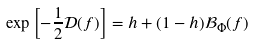Convert formula to latex. <formula><loc_0><loc_0><loc_500><loc_500>\exp \left [ - \frac { 1 } { 2 } \mathcal { D } ( f ) \right ] = h + ( 1 - h ) \mathcal { B } _ { \Phi } ( f )</formula> 